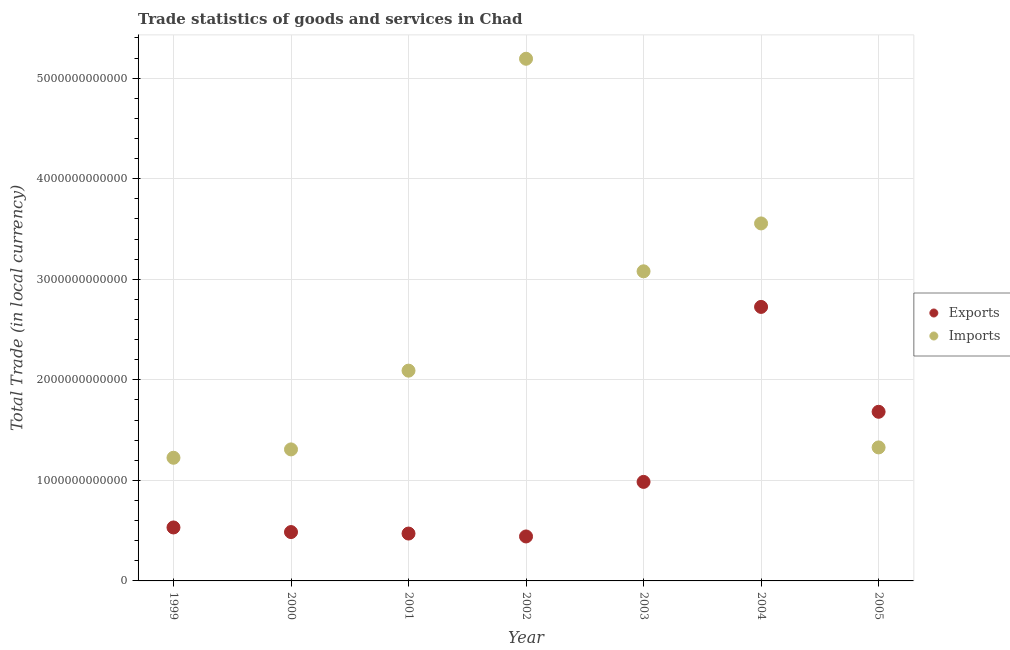How many different coloured dotlines are there?
Keep it short and to the point. 2. What is the imports of goods and services in 2004?
Give a very brief answer. 3.56e+12. Across all years, what is the maximum export of goods and services?
Offer a very short reply. 2.73e+12. Across all years, what is the minimum export of goods and services?
Your answer should be compact. 4.42e+11. In which year was the imports of goods and services maximum?
Your answer should be compact. 2002. What is the total export of goods and services in the graph?
Your response must be concise. 7.32e+12. What is the difference between the export of goods and services in 2001 and that in 2004?
Offer a terse response. -2.25e+12. What is the difference between the export of goods and services in 2001 and the imports of goods and services in 2000?
Give a very brief answer. -8.37e+11. What is the average imports of goods and services per year?
Keep it short and to the point. 2.54e+12. In the year 2000, what is the difference between the imports of goods and services and export of goods and services?
Your answer should be compact. 8.22e+11. In how many years, is the imports of goods and services greater than 2400000000000 LCU?
Your response must be concise. 3. What is the ratio of the imports of goods and services in 2000 to that in 2003?
Offer a very short reply. 0.42. What is the difference between the highest and the second highest imports of goods and services?
Your response must be concise. 1.64e+12. What is the difference between the highest and the lowest imports of goods and services?
Provide a short and direct response. 3.97e+12. Is the sum of the imports of goods and services in 2000 and 2003 greater than the maximum export of goods and services across all years?
Ensure brevity in your answer.  Yes. How many dotlines are there?
Your answer should be very brief. 2. What is the difference between two consecutive major ticks on the Y-axis?
Keep it short and to the point. 1.00e+12. Does the graph contain any zero values?
Ensure brevity in your answer.  No. What is the title of the graph?
Make the answer very short. Trade statistics of goods and services in Chad. What is the label or title of the X-axis?
Your answer should be very brief. Year. What is the label or title of the Y-axis?
Provide a short and direct response. Total Trade (in local currency). What is the Total Trade (in local currency) of Exports in 1999?
Your response must be concise. 5.32e+11. What is the Total Trade (in local currency) in Imports in 1999?
Ensure brevity in your answer.  1.22e+12. What is the Total Trade (in local currency) of Exports in 2000?
Give a very brief answer. 4.86e+11. What is the Total Trade (in local currency) in Imports in 2000?
Offer a terse response. 1.31e+12. What is the Total Trade (in local currency) of Exports in 2001?
Offer a very short reply. 4.71e+11. What is the Total Trade (in local currency) of Imports in 2001?
Provide a succinct answer. 2.09e+12. What is the Total Trade (in local currency) of Exports in 2002?
Provide a short and direct response. 4.42e+11. What is the Total Trade (in local currency) in Imports in 2002?
Your response must be concise. 5.19e+12. What is the Total Trade (in local currency) in Exports in 2003?
Make the answer very short. 9.85e+11. What is the Total Trade (in local currency) of Imports in 2003?
Offer a terse response. 3.08e+12. What is the Total Trade (in local currency) in Exports in 2004?
Your answer should be compact. 2.73e+12. What is the Total Trade (in local currency) of Imports in 2004?
Keep it short and to the point. 3.56e+12. What is the Total Trade (in local currency) of Exports in 2005?
Offer a very short reply. 1.68e+12. What is the Total Trade (in local currency) in Imports in 2005?
Your response must be concise. 1.33e+12. Across all years, what is the maximum Total Trade (in local currency) of Exports?
Offer a very short reply. 2.73e+12. Across all years, what is the maximum Total Trade (in local currency) of Imports?
Your response must be concise. 5.19e+12. Across all years, what is the minimum Total Trade (in local currency) of Exports?
Provide a succinct answer. 4.42e+11. Across all years, what is the minimum Total Trade (in local currency) of Imports?
Offer a terse response. 1.22e+12. What is the total Total Trade (in local currency) of Exports in the graph?
Provide a succinct answer. 7.32e+12. What is the total Total Trade (in local currency) of Imports in the graph?
Ensure brevity in your answer.  1.78e+13. What is the difference between the Total Trade (in local currency) of Exports in 1999 and that in 2000?
Ensure brevity in your answer.  4.58e+1. What is the difference between the Total Trade (in local currency) in Imports in 1999 and that in 2000?
Keep it short and to the point. -8.32e+1. What is the difference between the Total Trade (in local currency) in Exports in 1999 and that in 2001?
Your response must be concise. 6.06e+1. What is the difference between the Total Trade (in local currency) in Imports in 1999 and that in 2001?
Provide a short and direct response. -8.66e+11. What is the difference between the Total Trade (in local currency) of Exports in 1999 and that in 2002?
Keep it short and to the point. 8.94e+1. What is the difference between the Total Trade (in local currency) in Imports in 1999 and that in 2002?
Your answer should be very brief. -3.97e+12. What is the difference between the Total Trade (in local currency) of Exports in 1999 and that in 2003?
Offer a very short reply. -4.53e+11. What is the difference between the Total Trade (in local currency) in Imports in 1999 and that in 2003?
Give a very brief answer. -1.85e+12. What is the difference between the Total Trade (in local currency) of Exports in 1999 and that in 2004?
Offer a very short reply. -2.19e+12. What is the difference between the Total Trade (in local currency) in Imports in 1999 and that in 2004?
Give a very brief answer. -2.33e+12. What is the difference between the Total Trade (in local currency) in Exports in 1999 and that in 2005?
Your answer should be very brief. -1.15e+12. What is the difference between the Total Trade (in local currency) in Imports in 1999 and that in 2005?
Your answer should be compact. -1.03e+11. What is the difference between the Total Trade (in local currency) of Exports in 2000 and that in 2001?
Your response must be concise. 1.48e+1. What is the difference between the Total Trade (in local currency) in Imports in 2000 and that in 2001?
Provide a succinct answer. -7.83e+11. What is the difference between the Total Trade (in local currency) in Exports in 2000 and that in 2002?
Offer a very short reply. 4.37e+1. What is the difference between the Total Trade (in local currency) of Imports in 2000 and that in 2002?
Give a very brief answer. -3.88e+12. What is the difference between the Total Trade (in local currency) of Exports in 2000 and that in 2003?
Ensure brevity in your answer.  -4.99e+11. What is the difference between the Total Trade (in local currency) of Imports in 2000 and that in 2003?
Offer a very short reply. -1.77e+12. What is the difference between the Total Trade (in local currency) in Exports in 2000 and that in 2004?
Provide a short and direct response. -2.24e+12. What is the difference between the Total Trade (in local currency) in Imports in 2000 and that in 2004?
Make the answer very short. -2.25e+12. What is the difference between the Total Trade (in local currency) of Exports in 2000 and that in 2005?
Provide a short and direct response. -1.20e+12. What is the difference between the Total Trade (in local currency) in Imports in 2000 and that in 2005?
Your answer should be very brief. -1.97e+1. What is the difference between the Total Trade (in local currency) in Exports in 2001 and that in 2002?
Provide a short and direct response. 2.89e+1. What is the difference between the Total Trade (in local currency) in Imports in 2001 and that in 2002?
Your answer should be very brief. -3.10e+12. What is the difference between the Total Trade (in local currency) in Exports in 2001 and that in 2003?
Make the answer very short. -5.14e+11. What is the difference between the Total Trade (in local currency) in Imports in 2001 and that in 2003?
Your answer should be very brief. -9.88e+11. What is the difference between the Total Trade (in local currency) of Exports in 2001 and that in 2004?
Offer a very short reply. -2.25e+12. What is the difference between the Total Trade (in local currency) in Imports in 2001 and that in 2004?
Make the answer very short. -1.46e+12. What is the difference between the Total Trade (in local currency) of Exports in 2001 and that in 2005?
Ensure brevity in your answer.  -1.21e+12. What is the difference between the Total Trade (in local currency) of Imports in 2001 and that in 2005?
Ensure brevity in your answer.  7.63e+11. What is the difference between the Total Trade (in local currency) of Exports in 2002 and that in 2003?
Offer a very short reply. -5.43e+11. What is the difference between the Total Trade (in local currency) of Imports in 2002 and that in 2003?
Offer a very short reply. 2.11e+12. What is the difference between the Total Trade (in local currency) in Exports in 2002 and that in 2004?
Your response must be concise. -2.28e+12. What is the difference between the Total Trade (in local currency) in Imports in 2002 and that in 2004?
Your response must be concise. 1.64e+12. What is the difference between the Total Trade (in local currency) of Exports in 2002 and that in 2005?
Make the answer very short. -1.24e+12. What is the difference between the Total Trade (in local currency) of Imports in 2002 and that in 2005?
Keep it short and to the point. 3.87e+12. What is the difference between the Total Trade (in local currency) of Exports in 2003 and that in 2004?
Your answer should be compact. -1.74e+12. What is the difference between the Total Trade (in local currency) in Imports in 2003 and that in 2004?
Your response must be concise. -4.76e+11. What is the difference between the Total Trade (in local currency) of Exports in 2003 and that in 2005?
Your answer should be compact. -6.97e+11. What is the difference between the Total Trade (in local currency) in Imports in 2003 and that in 2005?
Give a very brief answer. 1.75e+12. What is the difference between the Total Trade (in local currency) in Exports in 2004 and that in 2005?
Your answer should be very brief. 1.04e+12. What is the difference between the Total Trade (in local currency) of Imports in 2004 and that in 2005?
Make the answer very short. 2.23e+12. What is the difference between the Total Trade (in local currency) of Exports in 1999 and the Total Trade (in local currency) of Imports in 2000?
Provide a succinct answer. -7.76e+11. What is the difference between the Total Trade (in local currency) of Exports in 1999 and the Total Trade (in local currency) of Imports in 2001?
Your answer should be very brief. -1.56e+12. What is the difference between the Total Trade (in local currency) in Exports in 1999 and the Total Trade (in local currency) in Imports in 2002?
Provide a short and direct response. -4.66e+12. What is the difference between the Total Trade (in local currency) of Exports in 1999 and the Total Trade (in local currency) of Imports in 2003?
Keep it short and to the point. -2.55e+12. What is the difference between the Total Trade (in local currency) in Exports in 1999 and the Total Trade (in local currency) in Imports in 2004?
Your response must be concise. -3.02e+12. What is the difference between the Total Trade (in local currency) of Exports in 1999 and the Total Trade (in local currency) of Imports in 2005?
Your answer should be very brief. -7.96e+11. What is the difference between the Total Trade (in local currency) of Exports in 2000 and the Total Trade (in local currency) of Imports in 2001?
Your answer should be compact. -1.61e+12. What is the difference between the Total Trade (in local currency) in Exports in 2000 and the Total Trade (in local currency) in Imports in 2002?
Your response must be concise. -4.71e+12. What is the difference between the Total Trade (in local currency) of Exports in 2000 and the Total Trade (in local currency) of Imports in 2003?
Offer a terse response. -2.59e+12. What is the difference between the Total Trade (in local currency) of Exports in 2000 and the Total Trade (in local currency) of Imports in 2004?
Make the answer very short. -3.07e+12. What is the difference between the Total Trade (in local currency) of Exports in 2000 and the Total Trade (in local currency) of Imports in 2005?
Provide a short and direct response. -8.42e+11. What is the difference between the Total Trade (in local currency) of Exports in 2001 and the Total Trade (in local currency) of Imports in 2002?
Ensure brevity in your answer.  -4.72e+12. What is the difference between the Total Trade (in local currency) of Exports in 2001 and the Total Trade (in local currency) of Imports in 2003?
Provide a succinct answer. -2.61e+12. What is the difference between the Total Trade (in local currency) in Exports in 2001 and the Total Trade (in local currency) in Imports in 2004?
Offer a very short reply. -3.08e+12. What is the difference between the Total Trade (in local currency) in Exports in 2001 and the Total Trade (in local currency) in Imports in 2005?
Provide a succinct answer. -8.57e+11. What is the difference between the Total Trade (in local currency) of Exports in 2002 and the Total Trade (in local currency) of Imports in 2003?
Keep it short and to the point. -2.64e+12. What is the difference between the Total Trade (in local currency) of Exports in 2002 and the Total Trade (in local currency) of Imports in 2004?
Your answer should be very brief. -3.11e+12. What is the difference between the Total Trade (in local currency) of Exports in 2002 and the Total Trade (in local currency) of Imports in 2005?
Ensure brevity in your answer.  -8.85e+11. What is the difference between the Total Trade (in local currency) of Exports in 2003 and the Total Trade (in local currency) of Imports in 2004?
Your answer should be compact. -2.57e+12. What is the difference between the Total Trade (in local currency) of Exports in 2003 and the Total Trade (in local currency) of Imports in 2005?
Give a very brief answer. -3.43e+11. What is the difference between the Total Trade (in local currency) in Exports in 2004 and the Total Trade (in local currency) in Imports in 2005?
Ensure brevity in your answer.  1.40e+12. What is the average Total Trade (in local currency) in Exports per year?
Make the answer very short. 1.05e+12. What is the average Total Trade (in local currency) of Imports per year?
Make the answer very short. 2.54e+12. In the year 1999, what is the difference between the Total Trade (in local currency) of Exports and Total Trade (in local currency) of Imports?
Your answer should be very brief. -6.93e+11. In the year 2000, what is the difference between the Total Trade (in local currency) of Exports and Total Trade (in local currency) of Imports?
Offer a very short reply. -8.22e+11. In the year 2001, what is the difference between the Total Trade (in local currency) of Exports and Total Trade (in local currency) of Imports?
Provide a short and direct response. -1.62e+12. In the year 2002, what is the difference between the Total Trade (in local currency) of Exports and Total Trade (in local currency) of Imports?
Your answer should be compact. -4.75e+12. In the year 2003, what is the difference between the Total Trade (in local currency) of Exports and Total Trade (in local currency) of Imports?
Offer a very short reply. -2.09e+12. In the year 2004, what is the difference between the Total Trade (in local currency) in Exports and Total Trade (in local currency) in Imports?
Provide a succinct answer. -8.30e+11. In the year 2005, what is the difference between the Total Trade (in local currency) in Exports and Total Trade (in local currency) in Imports?
Offer a terse response. 3.54e+11. What is the ratio of the Total Trade (in local currency) of Exports in 1999 to that in 2000?
Your answer should be very brief. 1.09. What is the ratio of the Total Trade (in local currency) in Imports in 1999 to that in 2000?
Provide a succinct answer. 0.94. What is the ratio of the Total Trade (in local currency) of Exports in 1999 to that in 2001?
Give a very brief answer. 1.13. What is the ratio of the Total Trade (in local currency) in Imports in 1999 to that in 2001?
Provide a short and direct response. 0.59. What is the ratio of the Total Trade (in local currency) of Exports in 1999 to that in 2002?
Ensure brevity in your answer.  1.2. What is the ratio of the Total Trade (in local currency) of Imports in 1999 to that in 2002?
Make the answer very short. 0.24. What is the ratio of the Total Trade (in local currency) in Exports in 1999 to that in 2003?
Offer a very short reply. 0.54. What is the ratio of the Total Trade (in local currency) in Imports in 1999 to that in 2003?
Keep it short and to the point. 0.4. What is the ratio of the Total Trade (in local currency) of Exports in 1999 to that in 2004?
Your response must be concise. 0.2. What is the ratio of the Total Trade (in local currency) of Imports in 1999 to that in 2004?
Provide a succinct answer. 0.34. What is the ratio of the Total Trade (in local currency) of Exports in 1999 to that in 2005?
Your answer should be compact. 0.32. What is the ratio of the Total Trade (in local currency) of Imports in 1999 to that in 2005?
Your answer should be compact. 0.92. What is the ratio of the Total Trade (in local currency) of Exports in 2000 to that in 2001?
Provide a short and direct response. 1.03. What is the ratio of the Total Trade (in local currency) of Imports in 2000 to that in 2001?
Your answer should be compact. 0.63. What is the ratio of the Total Trade (in local currency) of Exports in 2000 to that in 2002?
Your answer should be compact. 1.1. What is the ratio of the Total Trade (in local currency) of Imports in 2000 to that in 2002?
Your answer should be compact. 0.25. What is the ratio of the Total Trade (in local currency) of Exports in 2000 to that in 2003?
Offer a terse response. 0.49. What is the ratio of the Total Trade (in local currency) in Imports in 2000 to that in 2003?
Your answer should be very brief. 0.42. What is the ratio of the Total Trade (in local currency) of Exports in 2000 to that in 2004?
Provide a short and direct response. 0.18. What is the ratio of the Total Trade (in local currency) of Imports in 2000 to that in 2004?
Your response must be concise. 0.37. What is the ratio of the Total Trade (in local currency) of Exports in 2000 to that in 2005?
Offer a terse response. 0.29. What is the ratio of the Total Trade (in local currency) in Imports in 2000 to that in 2005?
Make the answer very short. 0.99. What is the ratio of the Total Trade (in local currency) of Exports in 2001 to that in 2002?
Offer a very short reply. 1.07. What is the ratio of the Total Trade (in local currency) in Imports in 2001 to that in 2002?
Provide a short and direct response. 0.4. What is the ratio of the Total Trade (in local currency) in Exports in 2001 to that in 2003?
Give a very brief answer. 0.48. What is the ratio of the Total Trade (in local currency) in Imports in 2001 to that in 2003?
Offer a terse response. 0.68. What is the ratio of the Total Trade (in local currency) of Exports in 2001 to that in 2004?
Offer a very short reply. 0.17. What is the ratio of the Total Trade (in local currency) of Imports in 2001 to that in 2004?
Offer a very short reply. 0.59. What is the ratio of the Total Trade (in local currency) of Exports in 2001 to that in 2005?
Ensure brevity in your answer.  0.28. What is the ratio of the Total Trade (in local currency) in Imports in 2001 to that in 2005?
Your answer should be very brief. 1.57. What is the ratio of the Total Trade (in local currency) of Exports in 2002 to that in 2003?
Make the answer very short. 0.45. What is the ratio of the Total Trade (in local currency) in Imports in 2002 to that in 2003?
Give a very brief answer. 1.69. What is the ratio of the Total Trade (in local currency) of Exports in 2002 to that in 2004?
Keep it short and to the point. 0.16. What is the ratio of the Total Trade (in local currency) of Imports in 2002 to that in 2004?
Your answer should be compact. 1.46. What is the ratio of the Total Trade (in local currency) of Exports in 2002 to that in 2005?
Provide a succinct answer. 0.26. What is the ratio of the Total Trade (in local currency) of Imports in 2002 to that in 2005?
Keep it short and to the point. 3.91. What is the ratio of the Total Trade (in local currency) of Exports in 2003 to that in 2004?
Keep it short and to the point. 0.36. What is the ratio of the Total Trade (in local currency) in Imports in 2003 to that in 2004?
Your answer should be very brief. 0.87. What is the ratio of the Total Trade (in local currency) in Exports in 2003 to that in 2005?
Your answer should be very brief. 0.59. What is the ratio of the Total Trade (in local currency) in Imports in 2003 to that in 2005?
Provide a short and direct response. 2.32. What is the ratio of the Total Trade (in local currency) in Exports in 2004 to that in 2005?
Give a very brief answer. 1.62. What is the ratio of the Total Trade (in local currency) in Imports in 2004 to that in 2005?
Make the answer very short. 2.68. What is the difference between the highest and the second highest Total Trade (in local currency) in Exports?
Provide a short and direct response. 1.04e+12. What is the difference between the highest and the second highest Total Trade (in local currency) of Imports?
Ensure brevity in your answer.  1.64e+12. What is the difference between the highest and the lowest Total Trade (in local currency) of Exports?
Keep it short and to the point. 2.28e+12. What is the difference between the highest and the lowest Total Trade (in local currency) of Imports?
Your answer should be compact. 3.97e+12. 